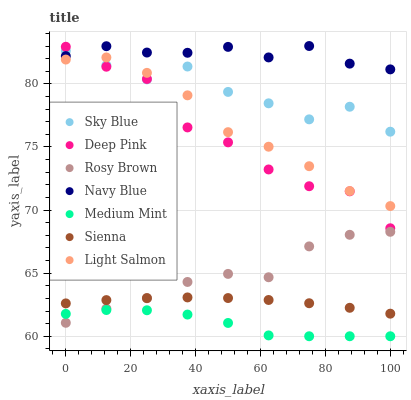Does Medium Mint have the minimum area under the curve?
Answer yes or no. Yes. Does Navy Blue have the maximum area under the curve?
Answer yes or no. Yes. Does Light Salmon have the minimum area under the curve?
Answer yes or no. No. Does Light Salmon have the maximum area under the curve?
Answer yes or no. No. Is Sienna the smoothest?
Answer yes or no. Yes. Is Sky Blue the roughest?
Answer yes or no. Yes. Is Light Salmon the smoothest?
Answer yes or no. No. Is Light Salmon the roughest?
Answer yes or no. No. Does Medium Mint have the lowest value?
Answer yes or no. Yes. Does Light Salmon have the lowest value?
Answer yes or no. No. Does Navy Blue have the highest value?
Answer yes or no. Yes. Does Light Salmon have the highest value?
Answer yes or no. No. Is Sienna less than Navy Blue?
Answer yes or no. Yes. Is Navy Blue greater than Sienna?
Answer yes or no. Yes. Does Rosy Brown intersect Sienna?
Answer yes or no. Yes. Is Rosy Brown less than Sienna?
Answer yes or no. No. Is Rosy Brown greater than Sienna?
Answer yes or no. No. Does Sienna intersect Navy Blue?
Answer yes or no. No. 